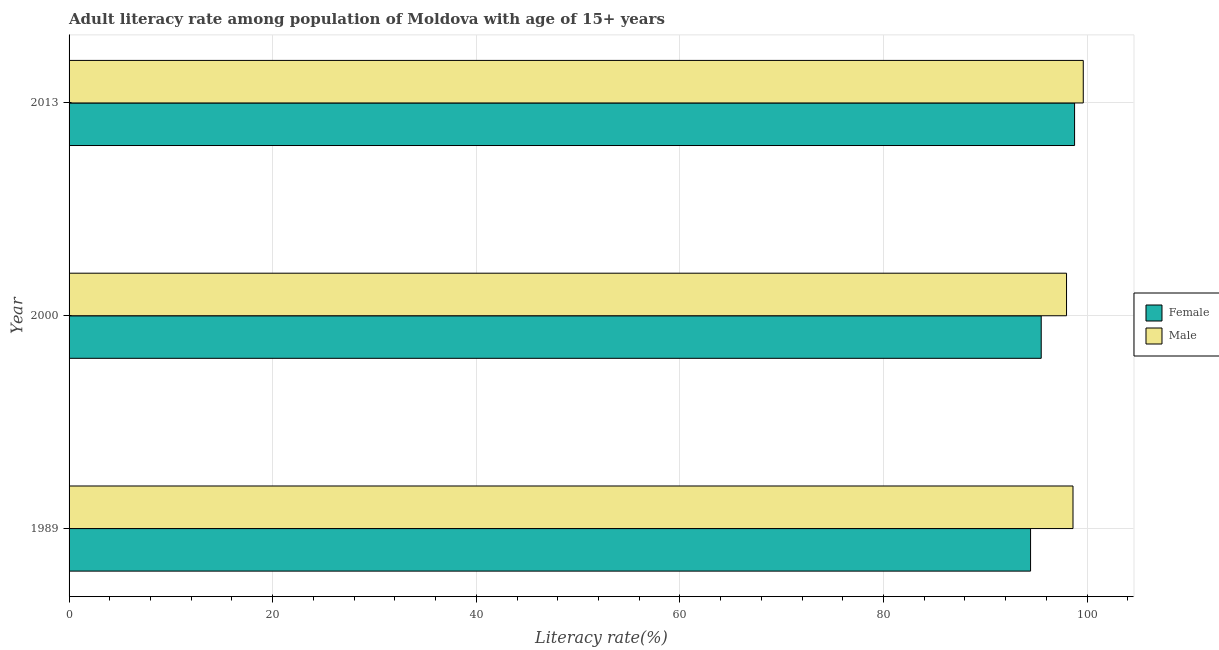How many different coloured bars are there?
Make the answer very short. 2. Are the number of bars per tick equal to the number of legend labels?
Give a very brief answer. Yes. How many bars are there on the 1st tick from the bottom?
Keep it short and to the point. 2. What is the label of the 1st group of bars from the top?
Keep it short and to the point. 2013. In how many cases, is the number of bars for a given year not equal to the number of legend labels?
Ensure brevity in your answer.  0. What is the male adult literacy rate in 2000?
Offer a terse response. 97.98. Across all years, what is the maximum female adult literacy rate?
Make the answer very short. 98.77. Across all years, what is the minimum male adult literacy rate?
Ensure brevity in your answer.  97.98. In which year was the female adult literacy rate maximum?
Your response must be concise. 2013. In which year was the male adult literacy rate minimum?
Your response must be concise. 2000. What is the total female adult literacy rate in the graph?
Provide a succinct answer. 288.71. What is the difference between the male adult literacy rate in 1989 and that in 2013?
Your answer should be compact. -1.01. What is the difference between the male adult literacy rate in 2000 and the female adult literacy rate in 2013?
Keep it short and to the point. -0.79. What is the average male adult literacy rate per year?
Make the answer very short. 98.74. In the year 2013, what is the difference between the female adult literacy rate and male adult literacy rate?
Offer a terse response. -0.85. In how many years, is the female adult literacy rate greater than 100 %?
Provide a short and direct response. 0. What is the ratio of the female adult literacy rate in 1989 to that in 2000?
Offer a terse response. 0.99. Is the difference between the female adult literacy rate in 2000 and 2013 greater than the difference between the male adult literacy rate in 2000 and 2013?
Keep it short and to the point. No. What is the difference between the highest and the second highest female adult literacy rate?
Offer a very short reply. 3.28. What is the difference between the highest and the lowest female adult literacy rate?
Provide a short and direct response. 4.32. Is the sum of the male adult literacy rate in 1989 and 2000 greater than the maximum female adult literacy rate across all years?
Give a very brief answer. Yes. What does the 1st bar from the top in 2000 represents?
Ensure brevity in your answer.  Male. What does the 2nd bar from the bottom in 1989 represents?
Offer a terse response. Male. Are all the bars in the graph horizontal?
Your answer should be compact. Yes. How many years are there in the graph?
Your answer should be very brief. 3. Does the graph contain grids?
Your answer should be very brief. Yes. How many legend labels are there?
Your answer should be compact. 2. How are the legend labels stacked?
Make the answer very short. Vertical. What is the title of the graph?
Give a very brief answer. Adult literacy rate among population of Moldova with age of 15+ years. What is the label or title of the X-axis?
Ensure brevity in your answer.  Literacy rate(%). What is the Literacy rate(%) of Female in 1989?
Give a very brief answer. 94.44. What is the Literacy rate(%) of Male in 1989?
Your answer should be very brief. 98.61. What is the Literacy rate(%) of Female in 2000?
Offer a very short reply. 95.49. What is the Literacy rate(%) of Male in 2000?
Provide a succinct answer. 97.98. What is the Literacy rate(%) in Female in 2013?
Ensure brevity in your answer.  98.77. What is the Literacy rate(%) in Male in 2013?
Your answer should be compact. 99.62. Across all years, what is the maximum Literacy rate(%) in Female?
Give a very brief answer. 98.77. Across all years, what is the maximum Literacy rate(%) in Male?
Your answer should be compact. 99.62. Across all years, what is the minimum Literacy rate(%) of Female?
Offer a very short reply. 94.44. Across all years, what is the minimum Literacy rate(%) of Male?
Offer a very short reply. 97.98. What is the total Literacy rate(%) of Female in the graph?
Provide a short and direct response. 288.71. What is the total Literacy rate(%) in Male in the graph?
Your answer should be compact. 296.21. What is the difference between the Literacy rate(%) in Female in 1989 and that in 2000?
Provide a short and direct response. -1.05. What is the difference between the Literacy rate(%) in Male in 1989 and that in 2000?
Your answer should be very brief. 0.64. What is the difference between the Literacy rate(%) in Female in 1989 and that in 2013?
Make the answer very short. -4.32. What is the difference between the Literacy rate(%) in Male in 1989 and that in 2013?
Give a very brief answer. -1.01. What is the difference between the Literacy rate(%) in Female in 2000 and that in 2013?
Keep it short and to the point. -3.28. What is the difference between the Literacy rate(%) of Male in 2000 and that in 2013?
Offer a very short reply. -1.64. What is the difference between the Literacy rate(%) of Female in 1989 and the Literacy rate(%) of Male in 2000?
Your answer should be compact. -3.53. What is the difference between the Literacy rate(%) of Female in 1989 and the Literacy rate(%) of Male in 2013?
Keep it short and to the point. -5.18. What is the difference between the Literacy rate(%) in Female in 2000 and the Literacy rate(%) in Male in 2013?
Offer a terse response. -4.13. What is the average Literacy rate(%) of Female per year?
Your answer should be compact. 96.24. What is the average Literacy rate(%) in Male per year?
Offer a very short reply. 98.74. In the year 1989, what is the difference between the Literacy rate(%) of Female and Literacy rate(%) of Male?
Offer a very short reply. -4.17. In the year 2000, what is the difference between the Literacy rate(%) in Female and Literacy rate(%) in Male?
Make the answer very short. -2.49. In the year 2013, what is the difference between the Literacy rate(%) of Female and Literacy rate(%) of Male?
Your response must be concise. -0.85. What is the ratio of the Literacy rate(%) of Female in 1989 to that in 2013?
Give a very brief answer. 0.96. What is the ratio of the Literacy rate(%) in Male in 1989 to that in 2013?
Keep it short and to the point. 0.99. What is the ratio of the Literacy rate(%) of Female in 2000 to that in 2013?
Give a very brief answer. 0.97. What is the ratio of the Literacy rate(%) of Male in 2000 to that in 2013?
Your answer should be very brief. 0.98. What is the difference between the highest and the second highest Literacy rate(%) in Female?
Offer a terse response. 3.28. What is the difference between the highest and the second highest Literacy rate(%) of Male?
Offer a very short reply. 1.01. What is the difference between the highest and the lowest Literacy rate(%) of Female?
Provide a short and direct response. 4.32. What is the difference between the highest and the lowest Literacy rate(%) in Male?
Ensure brevity in your answer.  1.64. 